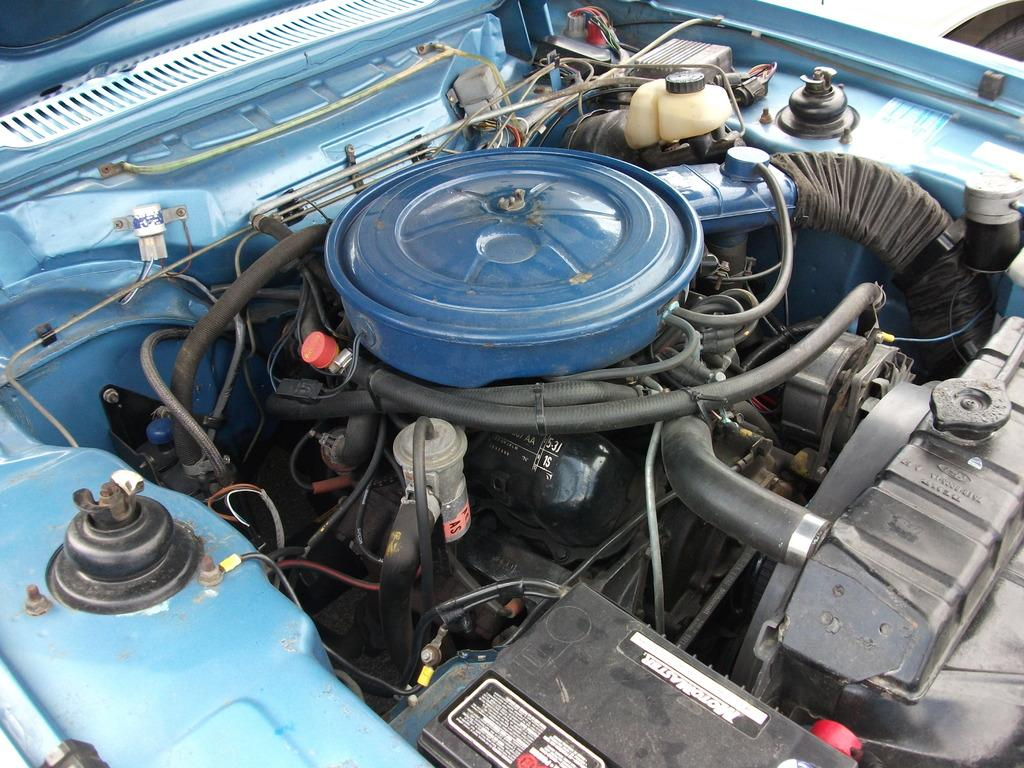What is the main subject of the image? The main subject of the image is an engine. What other components can be seen in the image? There are pipes, cables, screws, a battery, and other unspecified things related to a vehicle in the image. What might be used to connect or secure different parts in the image? The screws in the image might be used to connect or secure different parts. What type of power source is visible in the image? There is a battery visible in the image. Can you tell me how the vehicle is navigating through the quicksand in the image? There is no quicksand present in the image, and therefore no such navigation can be observed. 